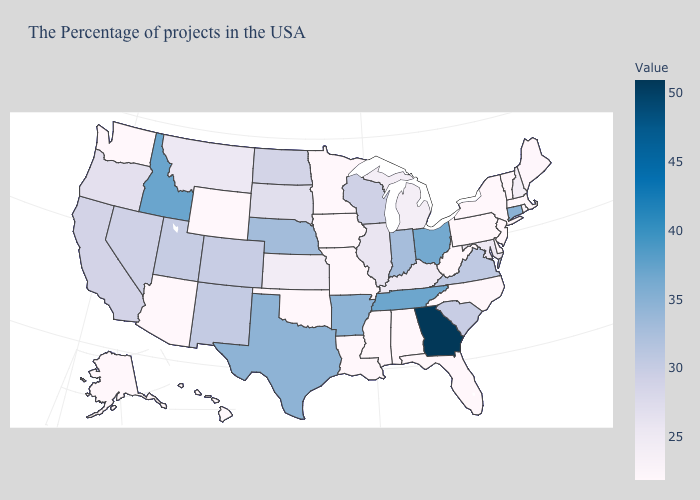Is the legend a continuous bar?
Keep it brief. Yes. Among the states that border New York , does Connecticut have the highest value?
Short answer required. Yes. Among the states that border Arkansas , does Louisiana have the lowest value?
Short answer required. Yes. Which states have the highest value in the USA?
Answer briefly. Georgia. Among the states that border Alabama , does Georgia have the highest value?
Give a very brief answer. Yes. Among the states that border Kansas , does Nebraska have the highest value?
Quick response, please. Yes. Which states have the lowest value in the Northeast?
Keep it brief. Massachusetts, Vermont, New York, New Jersey, Pennsylvania. 